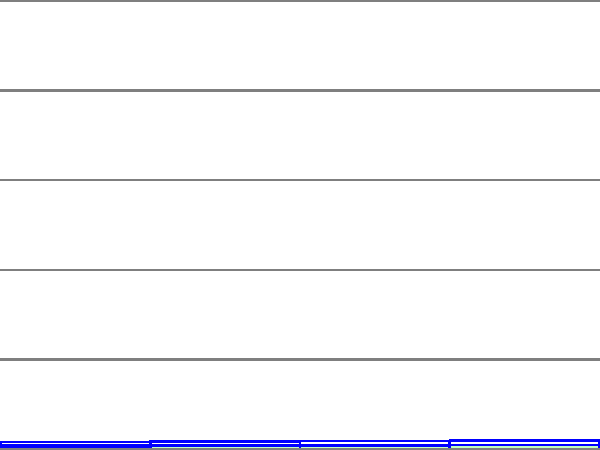Based on the bar graph showing the efficiency of different coffee waste processing methods, which method demonstrates the highest efficiency for reducing coffee farm waste? To determine the most efficient method for reducing coffee farm waste, we need to compare the efficiency percentages of each method shown in the bar graph:

1. Composting: 65% efficiency
2. Biogas: 78% efficiency
3. Biofuel: 82% efficiency
4. Mushroom Substrate: 90% efficiency

By comparing these values, we can see that the Mushroom Substrate method has the highest efficiency at 90%.

This method likely involves using coffee waste as a growing medium for mushrooms, which not only reduces waste but also produces a valuable product. The high efficiency suggests that this method is particularly effective at utilizing a large portion of the coffee waste, leaving minimal residual waste.

The other methods, while still effective, show lower efficiency rates:
- Biofuel (82%) and Biogas (78%) are both energy-producing methods that convert coffee waste into usable fuel sources.
- Composting (65%) is a traditional method of breaking down organic waste into nutrient-rich soil amendments.

For a food scientist researching innovative techniques for reducing coffee farm waste, the Mushroom Substrate method would be of particular interest due to its high efficiency and potential for creating a value-added product from waste materials.
Answer: Mushroom Substrate (90% efficiency) 